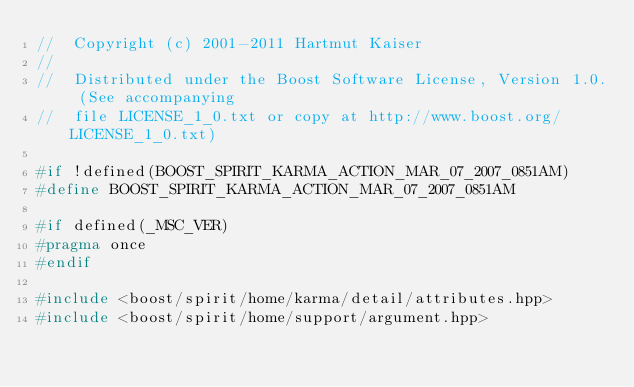Convert code to text. <code><loc_0><loc_0><loc_500><loc_500><_C++_>//  Copyright (c) 2001-2011 Hartmut Kaiser
//
//  Distributed under the Boost Software License, Version 1.0. (See accompanying
//  file LICENSE_1_0.txt or copy at http://www.boost.org/LICENSE_1_0.txt)

#if !defined(BOOST_SPIRIT_KARMA_ACTION_MAR_07_2007_0851AM)
#define BOOST_SPIRIT_KARMA_ACTION_MAR_07_2007_0851AM

#if defined(_MSC_VER)
#pragma once
#endif

#include <boost/spirit/home/karma/detail/attributes.hpp>
#include <boost/spirit/home/support/argument.hpp></code> 